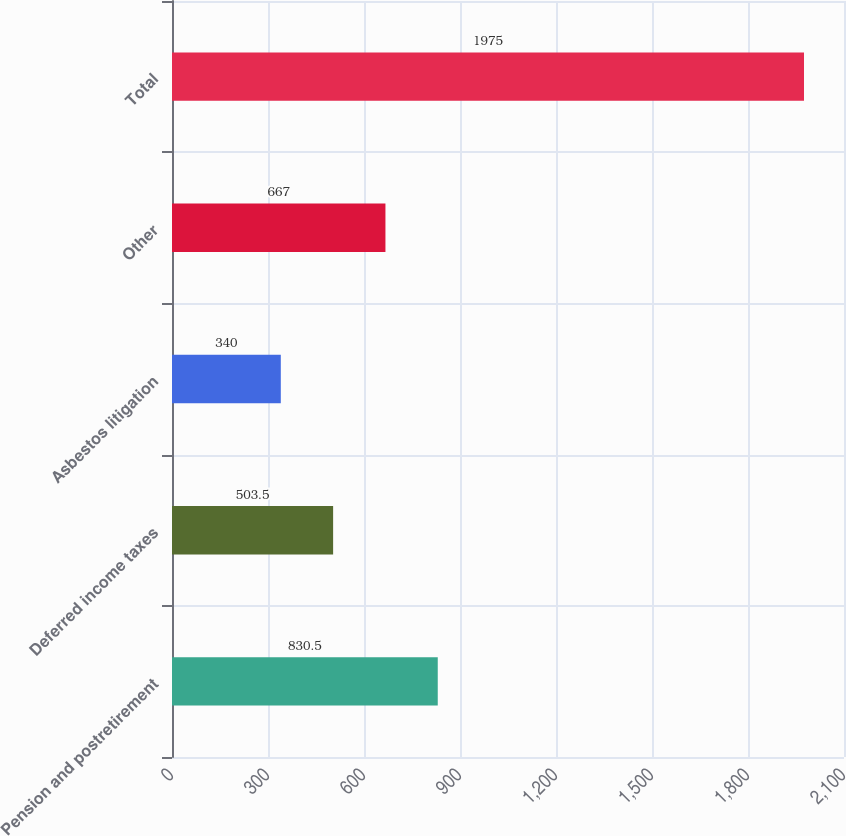Convert chart to OTSL. <chart><loc_0><loc_0><loc_500><loc_500><bar_chart><fcel>Pension and postretirement<fcel>Deferred income taxes<fcel>Asbestos litigation<fcel>Other<fcel>Total<nl><fcel>830.5<fcel>503.5<fcel>340<fcel>667<fcel>1975<nl></chart> 